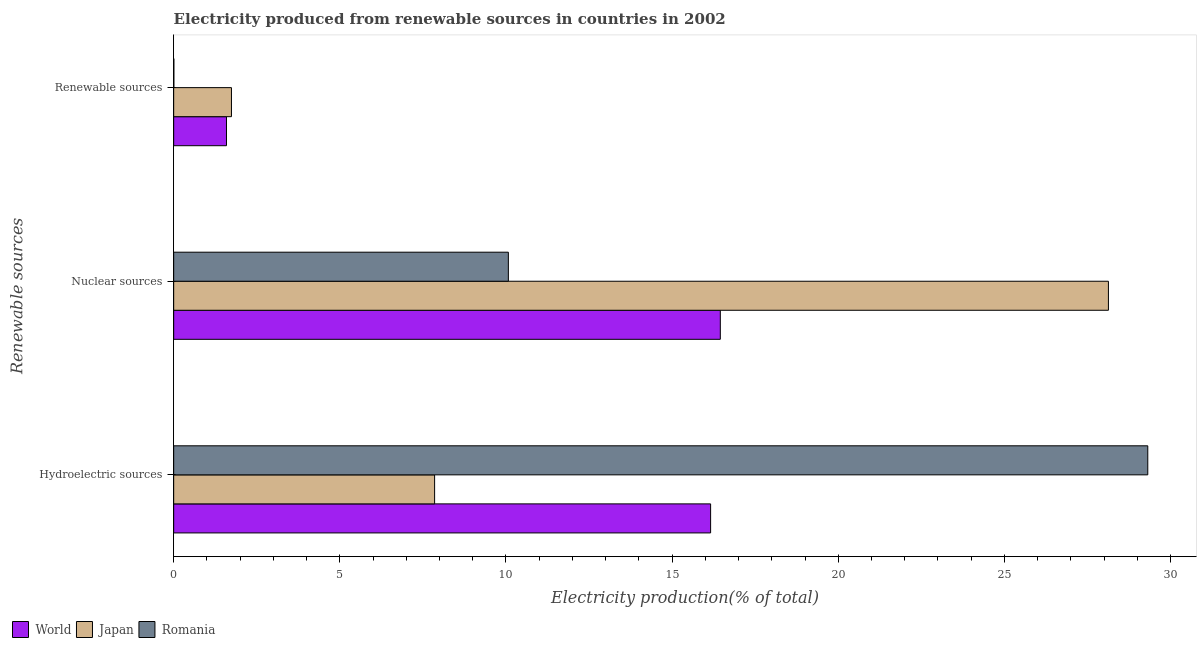What is the label of the 3rd group of bars from the top?
Your answer should be compact. Hydroelectric sources. What is the percentage of electricity produced by renewable sources in World?
Keep it short and to the point. 1.59. Across all countries, what is the maximum percentage of electricity produced by renewable sources?
Make the answer very short. 1.74. Across all countries, what is the minimum percentage of electricity produced by renewable sources?
Give a very brief answer. 0.01. In which country was the percentage of electricity produced by renewable sources minimum?
Make the answer very short. Romania. What is the total percentage of electricity produced by nuclear sources in the graph?
Make the answer very short. 54.65. What is the difference between the percentage of electricity produced by nuclear sources in Japan and that in World?
Give a very brief answer. 11.68. What is the difference between the percentage of electricity produced by renewable sources in Japan and the percentage of electricity produced by nuclear sources in Romania?
Your answer should be compact. -8.33. What is the average percentage of electricity produced by hydroelectric sources per country?
Keep it short and to the point. 17.78. What is the difference between the percentage of electricity produced by hydroelectric sources and percentage of electricity produced by renewable sources in Romania?
Your answer should be very brief. 29.31. In how many countries, is the percentage of electricity produced by hydroelectric sources greater than 5 %?
Your answer should be very brief. 3. What is the ratio of the percentage of electricity produced by nuclear sources in Japan to that in Romania?
Provide a succinct answer. 2.79. Is the difference between the percentage of electricity produced by nuclear sources in World and Japan greater than the difference between the percentage of electricity produced by renewable sources in World and Japan?
Ensure brevity in your answer.  No. What is the difference between the highest and the second highest percentage of electricity produced by hydroelectric sources?
Provide a succinct answer. 13.16. What is the difference between the highest and the lowest percentage of electricity produced by nuclear sources?
Your answer should be compact. 18.06. Is the sum of the percentage of electricity produced by renewable sources in Japan and Romania greater than the maximum percentage of electricity produced by nuclear sources across all countries?
Your answer should be compact. No. What does the 1st bar from the top in Hydroelectric sources represents?
Keep it short and to the point. Romania. What does the 1st bar from the bottom in Hydroelectric sources represents?
Ensure brevity in your answer.  World. How many bars are there?
Make the answer very short. 9. Are all the bars in the graph horizontal?
Offer a terse response. Yes. How many countries are there in the graph?
Make the answer very short. 3. Are the values on the major ticks of X-axis written in scientific E-notation?
Your answer should be compact. No. Does the graph contain any zero values?
Keep it short and to the point. No. Does the graph contain grids?
Keep it short and to the point. No. Where does the legend appear in the graph?
Give a very brief answer. Bottom left. How are the legend labels stacked?
Offer a terse response. Horizontal. What is the title of the graph?
Offer a terse response. Electricity produced from renewable sources in countries in 2002. What is the label or title of the X-axis?
Your answer should be compact. Electricity production(% of total). What is the label or title of the Y-axis?
Your response must be concise. Renewable sources. What is the Electricity production(% of total) in World in Hydroelectric sources?
Make the answer very short. 16.16. What is the Electricity production(% of total) of Japan in Hydroelectric sources?
Your response must be concise. 7.85. What is the Electricity production(% of total) in Romania in Hydroelectric sources?
Make the answer very short. 29.32. What is the Electricity production(% of total) in World in Nuclear sources?
Your answer should be compact. 16.45. What is the Electricity production(% of total) of Japan in Nuclear sources?
Offer a terse response. 28.13. What is the Electricity production(% of total) of Romania in Nuclear sources?
Offer a very short reply. 10.07. What is the Electricity production(% of total) in World in Renewable sources?
Give a very brief answer. 1.59. What is the Electricity production(% of total) in Japan in Renewable sources?
Ensure brevity in your answer.  1.74. What is the Electricity production(% of total) in Romania in Renewable sources?
Offer a terse response. 0.01. Across all Renewable sources, what is the maximum Electricity production(% of total) in World?
Ensure brevity in your answer.  16.45. Across all Renewable sources, what is the maximum Electricity production(% of total) of Japan?
Make the answer very short. 28.13. Across all Renewable sources, what is the maximum Electricity production(% of total) of Romania?
Provide a short and direct response. 29.32. Across all Renewable sources, what is the minimum Electricity production(% of total) in World?
Your response must be concise. 1.59. Across all Renewable sources, what is the minimum Electricity production(% of total) of Japan?
Offer a terse response. 1.74. Across all Renewable sources, what is the minimum Electricity production(% of total) of Romania?
Provide a succinct answer. 0.01. What is the total Electricity production(% of total) of World in the graph?
Your response must be concise. 34.2. What is the total Electricity production(% of total) in Japan in the graph?
Offer a terse response. 37.72. What is the total Electricity production(% of total) in Romania in the graph?
Your response must be concise. 39.39. What is the difference between the Electricity production(% of total) of World in Hydroelectric sources and that in Nuclear sources?
Provide a succinct answer. -0.29. What is the difference between the Electricity production(% of total) in Japan in Hydroelectric sources and that in Nuclear sources?
Make the answer very short. -20.28. What is the difference between the Electricity production(% of total) of Romania in Hydroelectric sources and that in Nuclear sources?
Keep it short and to the point. 19.24. What is the difference between the Electricity production(% of total) in World in Hydroelectric sources and that in Renewable sources?
Keep it short and to the point. 14.57. What is the difference between the Electricity production(% of total) of Japan in Hydroelectric sources and that in Renewable sources?
Make the answer very short. 6.11. What is the difference between the Electricity production(% of total) of Romania in Hydroelectric sources and that in Renewable sources?
Provide a short and direct response. 29.31. What is the difference between the Electricity production(% of total) in World in Nuclear sources and that in Renewable sources?
Keep it short and to the point. 14.86. What is the difference between the Electricity production(% of total) in Japan in Nuclear sources and that in Renewable sources?
Provide a short and direct response. 26.39. What is the difference between the Electricity production(% of total) of Romania in Nuclear sources and that in Renewable sources?
Your answer should be compact. 10.07. What is the difference between the Electricity production(% of total) in World in Hydroelectric sources and the Electricity production(% of total) in Japan in Nuclear sources?
Provide a succinct answer. -11.97. What is the difference between the Electricity production(% of total) in World in Hydroelectric sources and the Electricity production(% of total) in Romania in Nuclear sources?
Provide a succinct answer. 6.09. What is the difference between the Electricity production(% of total) of Japan in Hydroelectric sources and the Electricity production(% of total) of Romania in Nuclear sources?
Provide a succinct answer. -2.22. What is the difference between the Electricity production(% of total) of World in Hydroelectric sources and the Electricity production(% of total) of Japan in Renewable sources?
Your answer should be compact. 14.42. What is the difference between the Electricity production(% of total) in World in Hydroelectric sources and the Electricity production(% of total) in Romania in Renewable sources?
Offer a terse response. 16.15. What is the difference between the Electricity production(% of total) in Japan in Hydroelectric sources and the Electricity production(% of total) in Romania in Renewable sources?
Keep it short and to the point. 7.85. What is the difference between the Electricity production(% of total) of World in Nuclear sources and the Electricity production(% of total) of Japan in Renewable sources?
Ensure brevity in your answer.  14.71. What is the difference between the Electricity production(% of total) of World in Nuclear sources and the Electricity production(% of total) of Romania in Renewable sources?
Provide a short and direct response. 16.45. What is the difference between the Electricity production(% of total) of Japan in Nuclear sources and the Electricity production(% of total) of Romania in Renewable sources?
Your answer should be very brief. 28.13. What is the average Electricity production(% of total) of World per Renewable sources?
Provide a succinct answer. 11.4. What is the average Electricity production(% of total) of Japan per Renewable sources?
Your answer should be very brief. 12.57. What is the average Electricity production(% of total) in Romania per Renewable sources?
Your response must be concise. 13.13. What is the difference between the Electricity production(% of total) in World and Electricity production(% of total) in Japan in Hydroelectric sources?
Your answer should be very brief. 8.31. What is the difference between the Electricity production(% of total) in World and Electricity production(% of total) in Romania in Hydroelectric sources?
Offer a terse response. -13.16. What is the difference between the Electricity production(% of total) of Japan and Electricity production(% of total) of Romania in Hydroelectric sources?
Ensure brevity in your answer.  -21.46. What is the difference between the Electricity production(% of total) of World and Electricity production(% of total) of Japan in Nuclear sources?
Your response must be concise. -11.68. What is the difference between the Electricity production(% of total) in World and Electricity production(% of total) in Romania in Nuclear sources?
Keep it short and to the point. 6.38. What is the difference between the Electricity production(% of total) of Japan and Electricity production(% of total) of Romania in Nuclear sources?
Keep it short and to the point. 18.06. What is the difference between the Electricity production(% of total) in World and Electricity production(% of total) in Japan in Renewable sources?
Keep it short and to the point. -0.15. What is the difference between the Electricity production(% of total) of World and Electricity production(% of total) of Romania in Renewable sources?
Your answer should be compact. 1.58. What is the difference between the Electricity production(% of total) of Japan and Electricity production(% of total) of Romania in Renewable sources?
Provide a short and direct response. 1.73. What is the ratio of the Electricity production(% of total) of World in Hydroelectric sources to that in Nuclear sources?
Your response must be concise. 0.98. What is the ratio of the Electricity production(% of total) in Japan in Hydroelectric sources to that in Nuclear sources?
Your answer should be very brief. 0.28. What is the ratio of the Electricity production(% of total) of Romania in Hydroelectric sources to that in Nuclear sources?
Give a very brief answer. 2.91. What is the ratio of the Electricity production(% of total) of World in Hydroelectric sources to that in Renewable sources?
Provide a succinct answer. 10.17. What is the ratio of the Electricity production(% of total) of Japan in Hydroelectric sources to that in Renewable sources?
Provide a succinct answer. 4.52. What is the ratio of the Electricity production(% of total) of Romania in Hydroelectric sources to that in Renewable sources?
Provide a succinct answer. 5348.67. What is the ratio of the Electricity production(% of total) of World in Nuclear sources to that in Renewable sources?
Make the answer very short. 10.35. What is the ratio of the Electricity production(% of total) of Japan in Nuclear sources to that in Renewable sources?
Provide a short and direct response. 16.18. What is the ratio of the Electricity production(% of total) of Romania in Nuclear sources to that in Renewable sources?
Keep it short and to the point. 1837.67. What is the difference between the highest and the second highest Electricity production(% of total) in World?
Ensure brevity in your answer.  0.29. What is the difference between the highest and the second highest Electricity production(% of total) of Japan?
Offer a very short reply. 20.28. What is the difference between the highest and the second highest Electricity production(% of total) of Romania?
Your answer should be compact. 19.24. What is the difference between the highest and the lowest Electricity production(% of total) of World?
Give a very brief answer. 14.86. What is the difference between the highest and the lowest Electricity production(% of total) in Japan?
Provide a succinct answer. 26.39. What is the difference between the highest and the lowest Electricity production(% of total) in Romania?
Ensure brevity in your answer.  29.31. 